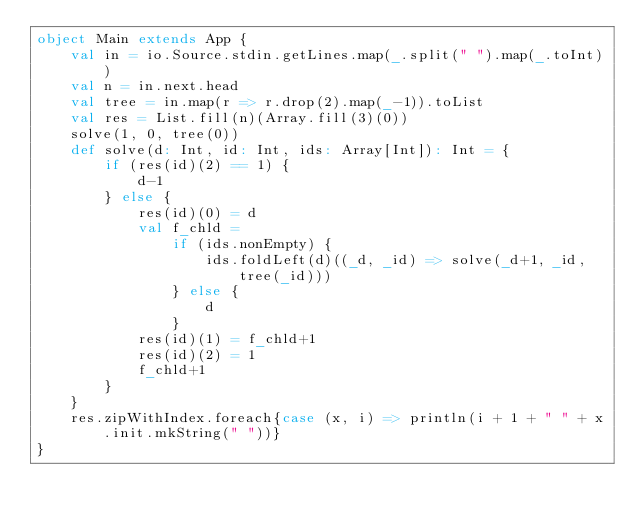<code> <loc_0><loc_0><loc_500><loc_500><_Scala_>object Main extends App {
    val in = io.Source.stdin.getLines.map(_.split(" ").map(_.toInt))
    val n = in.next.head
    val tree = in.map(r => r.drop(2).map(_-1)).toList
    val res = List.fill(n)(Array.fill(3)(0))
    solve(1, 0, tree(0))
    def solve(d: Int, id: Int, ids: Array[Int]): Int = {
        if (res(id)(2) == 1) {
            d-1
        } else {
            res(id)(0) = d
            val f_chld =
                if (ids.nonEmpty) {
                    ids.foldLeft(d)((_d, _id) => solve(_d+1, _id, tree(_id)))
                } else {
                    d
                }
            res(id)(1) = f_chld+1
            res(id)(2) = 1
            f_chld+1
        }
    }
    res.zipWithIndex.foreach{case (x, i) => println(i + 1 + " " + x.init.mkString(" "))}
}</code> 